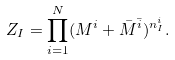<formula> <loc_0><loc_0><loc_500><loc_500>Z _ { I } = \prod _ { i = 1 } ^ { N } ( M ^ { i } + \bar { M } ^ { \bar { i } } ) ^ { n _ { I } ^ { i } } .</formula> 